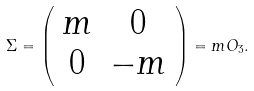<formula> <loc_0><loc_0><loc_500><loc_500>\Sigma = \left ( \begin{array} { c c } { m } & { 0 } \\ { 0 } & { - m } \end{array} \right ) = m O _ { 3 } .</formula> 